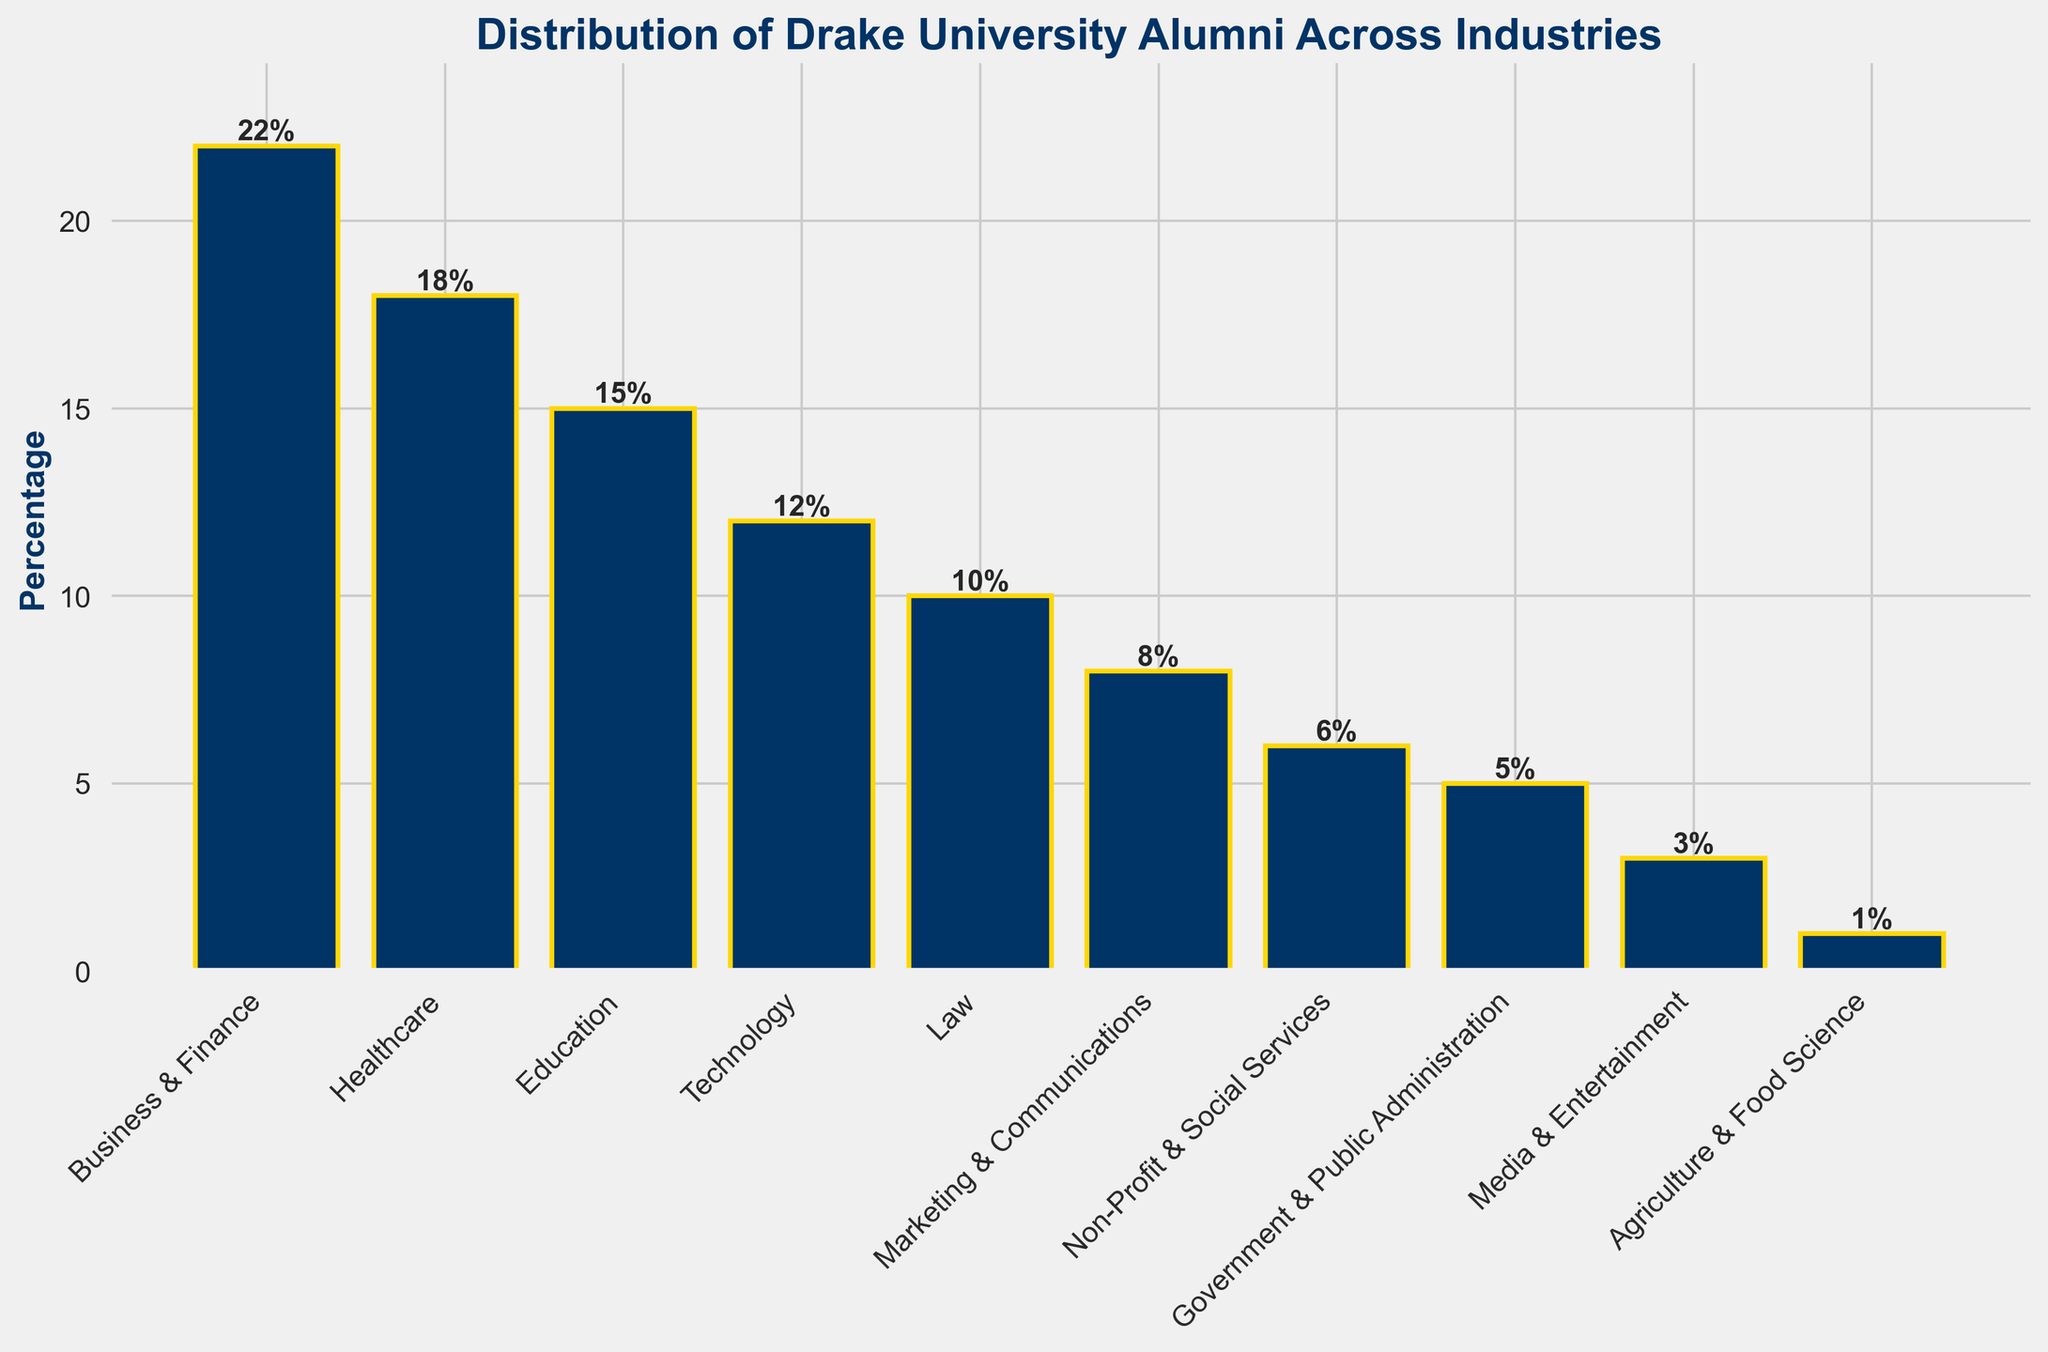What's the most common industry among Drake University alumni? Look for the bar with the greatest height in the chart. The "Business & Finance" bar is the tallest.
Answer: Business & Finance In which industry do fewer than 10% of Drake University alumni work? Identify the bars that do not reach the 10% mark on the chart's y-axis. These are "Marketing & Communications," "Non-Profit & Social Services," "Government & Public Administration," "Media & Entertainment," and "Agriculture & Food Science."
Answer: Marketing & Communications, Non-Profit & Social Services, Government & Public Administration, Media & Entertainment, Agriculture & Food Science By how much does the percentage of alumni in Healthcare exceed those in Technology? Find the heights of the bars for Healthcare and Technology. Healthcare is at 18%, and Technology is at 12%. Subtract the two values: 18% - 12% = 6%
Answer: 6% What is the combined percentage of alumni working in Education, Law, and Technology? Add the heights of the bars for Education, Law, and Technology. Education is 15%, Law is 10%, and Technology is 12%. 15% + 10% + 12% = 37%
Answer: 37% Which industry has the least number of Drake University alumni working in it? Look for the bar with the smallest height in the chart. The "Agriculture & Food Science" bar is the shortest at 1%.
Answer: Agriculture & Food Science Compare the percentages of alumni in Business & Finance and Media & Entertainment. Which one is higher and by how much? Compare the heights of the bars for Business & Finance (22%) and Media & Entertainment (3%). Subtract the two values: 22% - 3% = 19%. Business & Finance has a higher percentage.
Answer: Business & Finance, by 19% What is the average percentage of alumni working across Law, Marketing & Communications, and Non-Profit & Social Services? Add the heights of the bars for Law (10%), Marketing & Communications (8%), and Non-Profit & Social Services (6%), then divide by 3 for the average. (10% + 8% + 6%) / 3 = 8%.
Answer: 8% By what factor do the percentages of alumni in Business & Finance exceed those in Agriculture & Food Science? Divide the percentage of Business & Finance alumni (22%) by the percentage of Agriculture & Food Science alumni (1%). 22% / 1% = 22.
Answer: 22 How many industries have more than 10% of alumni working in them? Count the number of bars that exceed the 10% mark on the y-axis. These are Business & Finance, Healthcare, Education, Technology, and Law.
Answer: 5 